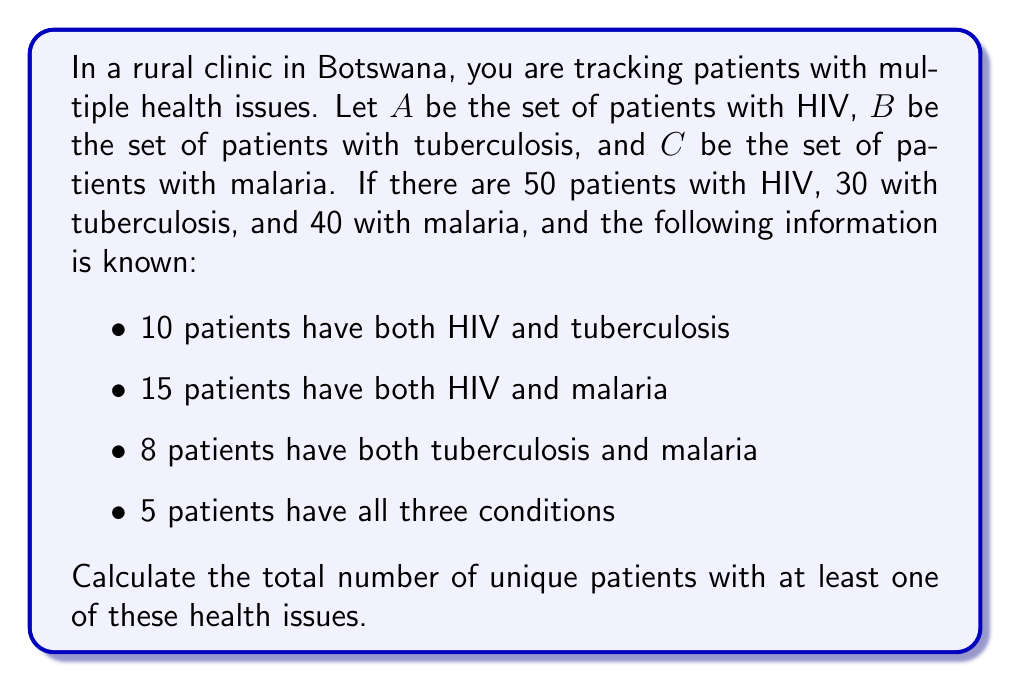Give your solution to this math problem. To solve this problem, we need to use the principle of inclusion-exclusion for three sets. The formula for the cardinality of the union of three sets is:

$$|A \cup B \cup C| = |A| + |B| + |C| - |A \cap B| - |A \cap C| - |B \cap C| + |A \cap B \cap C|$$

Let's substitute the given values:

1. $|A| = 50$ (patients with HIV)
2. $|B| = 30$ (patients with tuberculosis)
3. $|C| = 40$ (patients with malaria)
4. $|A \cap B| = 10$ (patients with both HIV and tuberculosis)
5. $|A \cap C| = 15$ (patients with both HIV and malaria)
6. $|B \cap C| = 8$ (patients with both tuberculosis and malaria)
7. $|A \cap B \cap C| = 5$ (patients with all three conditions)

Now, let's calculate:

$$\begin{align*}
|A \cup B \cup C| &= |A| + |B| + |C| - |A \cap B| - |A \cap C| - |B \cap C| + |A \cap B \cap C| \\
&= 50 + 30 + 40 - 10 - 15 - 8 + 5 \\
&= 120 - 33 + 5 \\
&= 92
\end{align*}$$

Therefore, the total number of unique patients with at least one of these health issues is 92.
Answer: 92 patients 